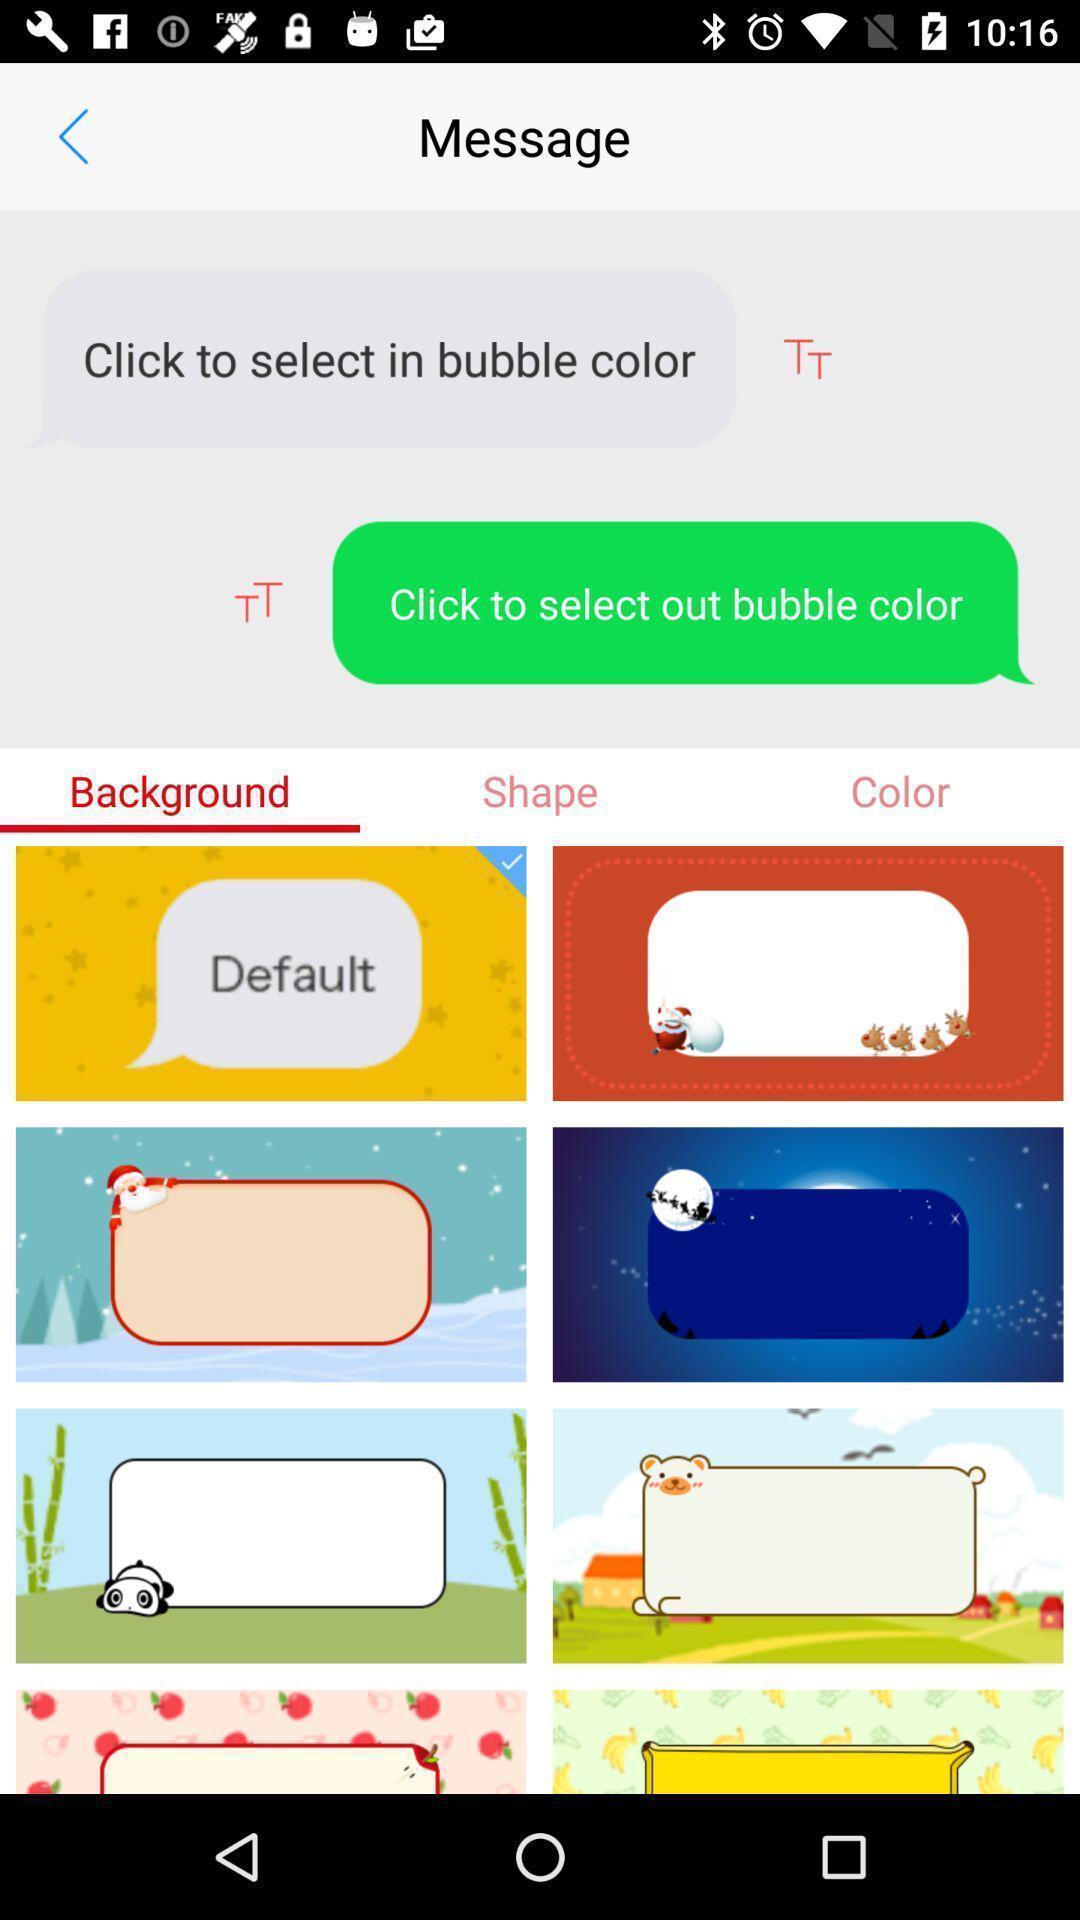Tell me about the visual elements in this screen capture. Screen page displaying various options in social application. 